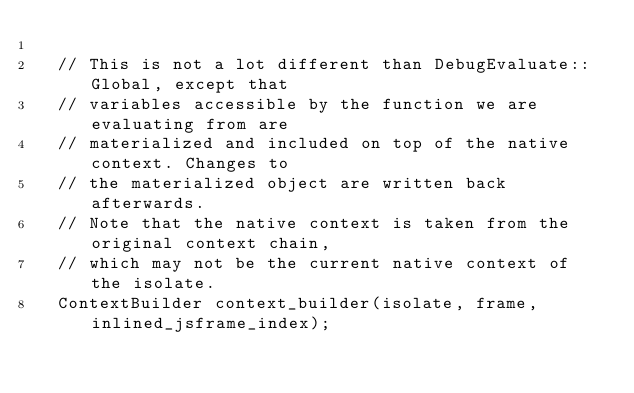<code> <loc_0><loc_0><loc_500><loc_500><_C++_>
  // This is not a lot different than DebugEvaluate::Global, except that
  // variables accessible by the function we are evaluating from are
  // materialized and included on top of the native context. Changes to
  // the materialized object are written back afterwards.
  // Note that the native context is taken from the original context chain,
  // which may not be the current native context of the isolate.
  ContextBuilder context_builder(isolate, frame, inlined_jsframe_index);</code> 